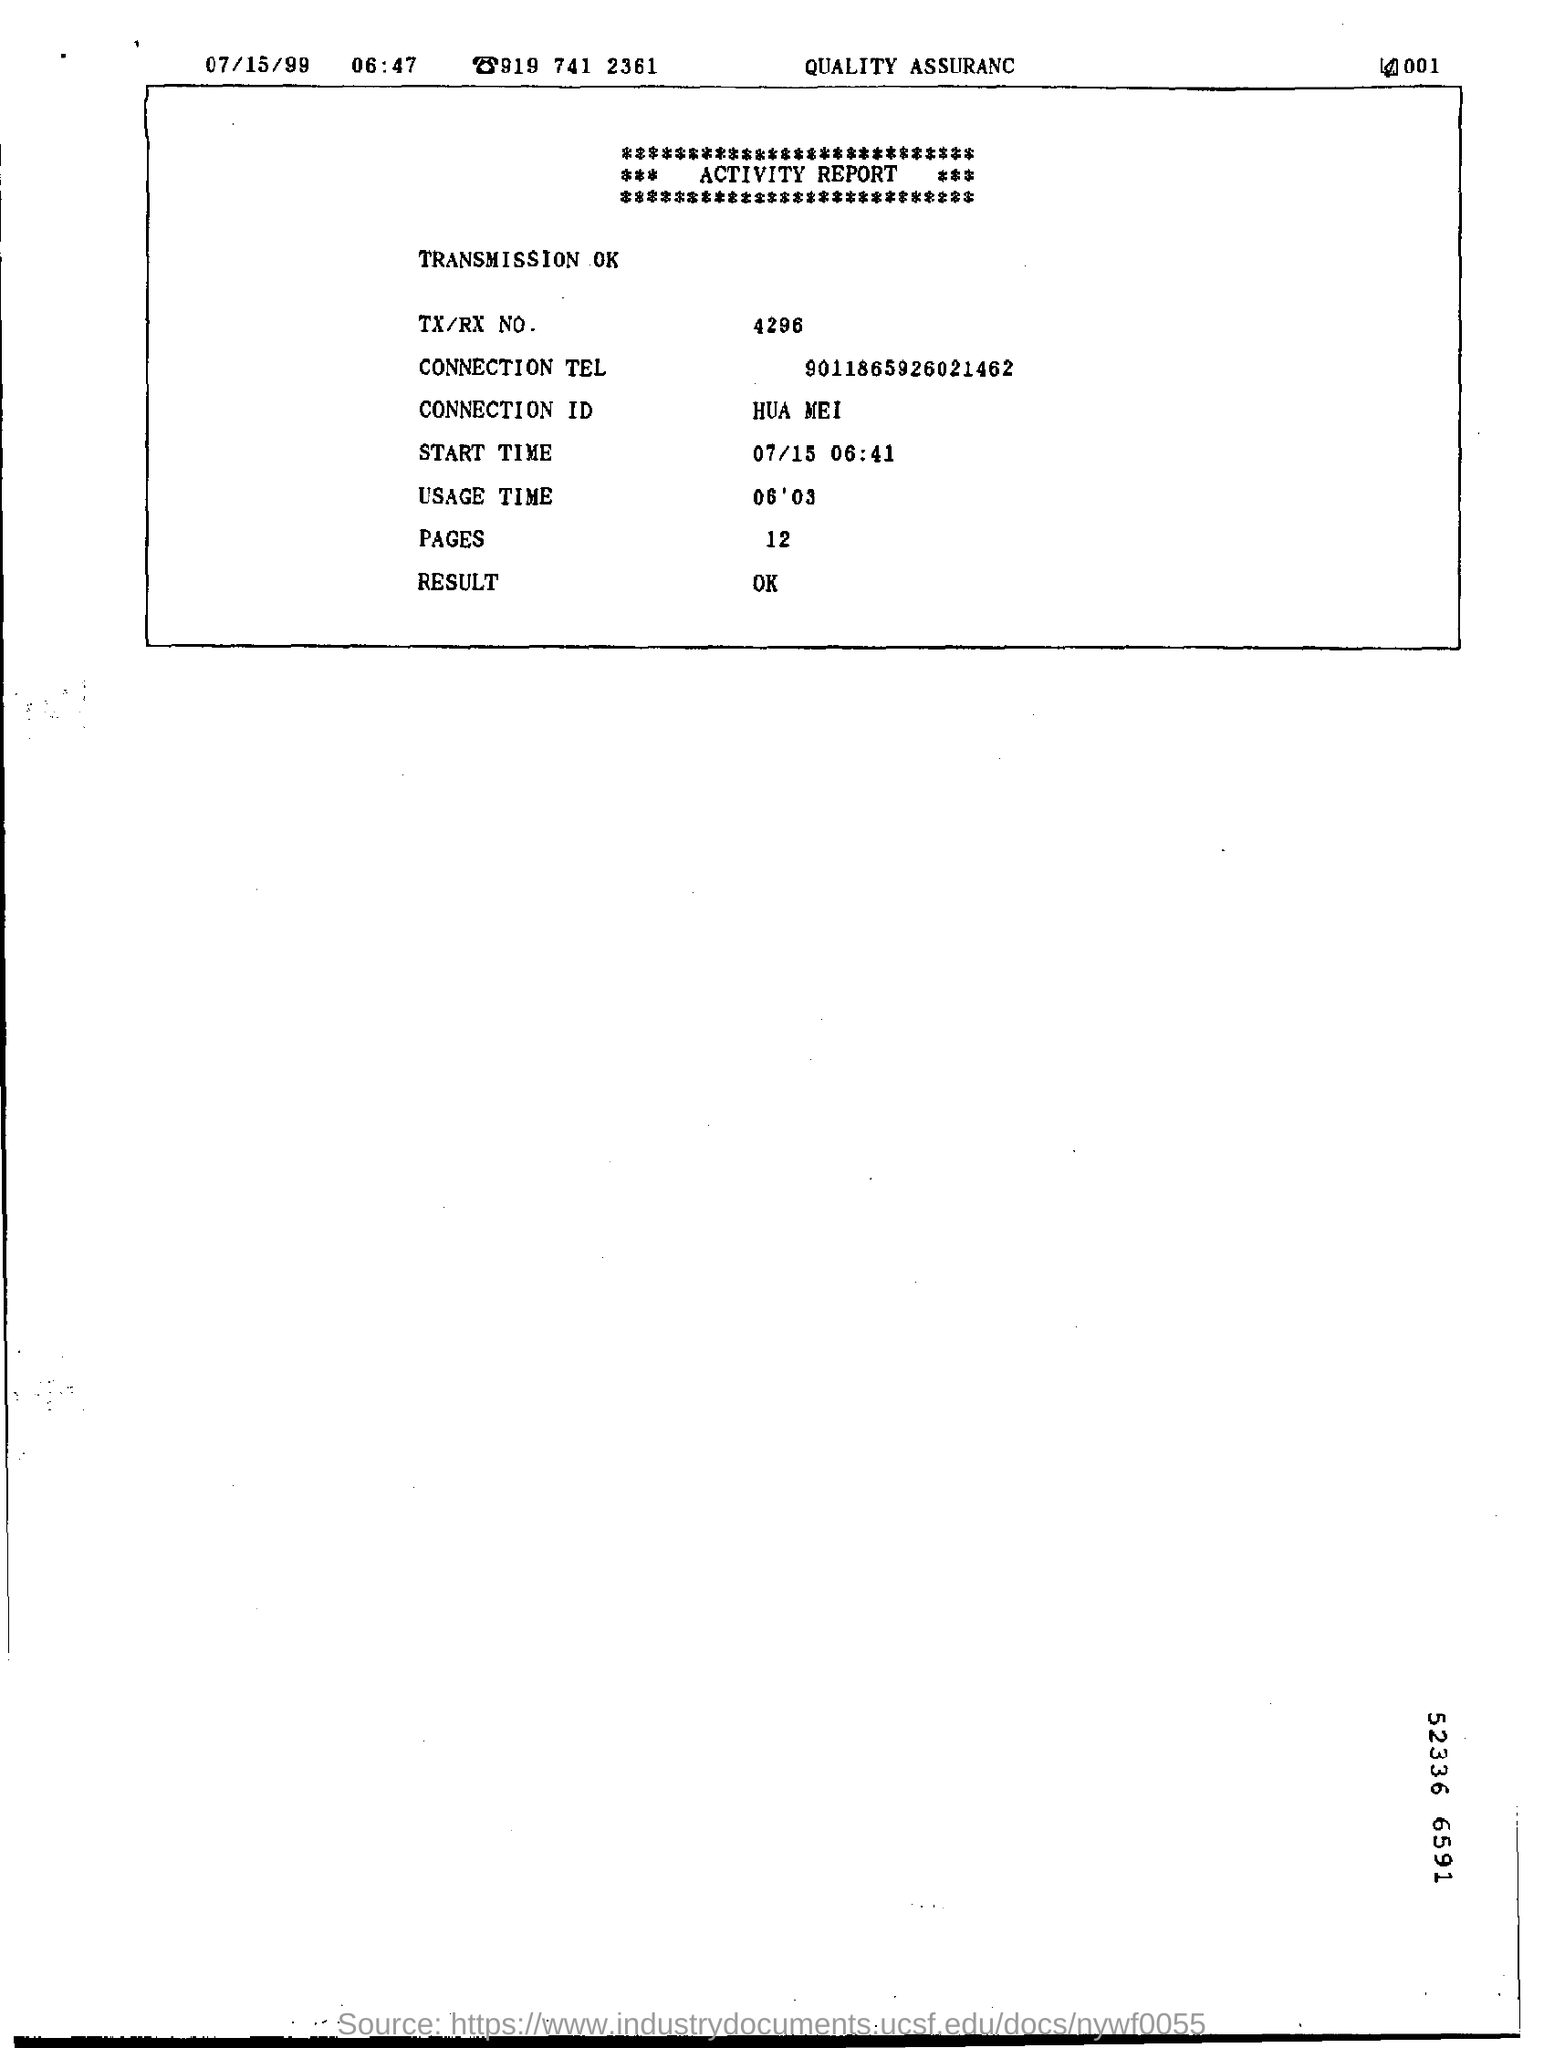What is the connection id?
Keep it short and to the point. HUA MEI. 